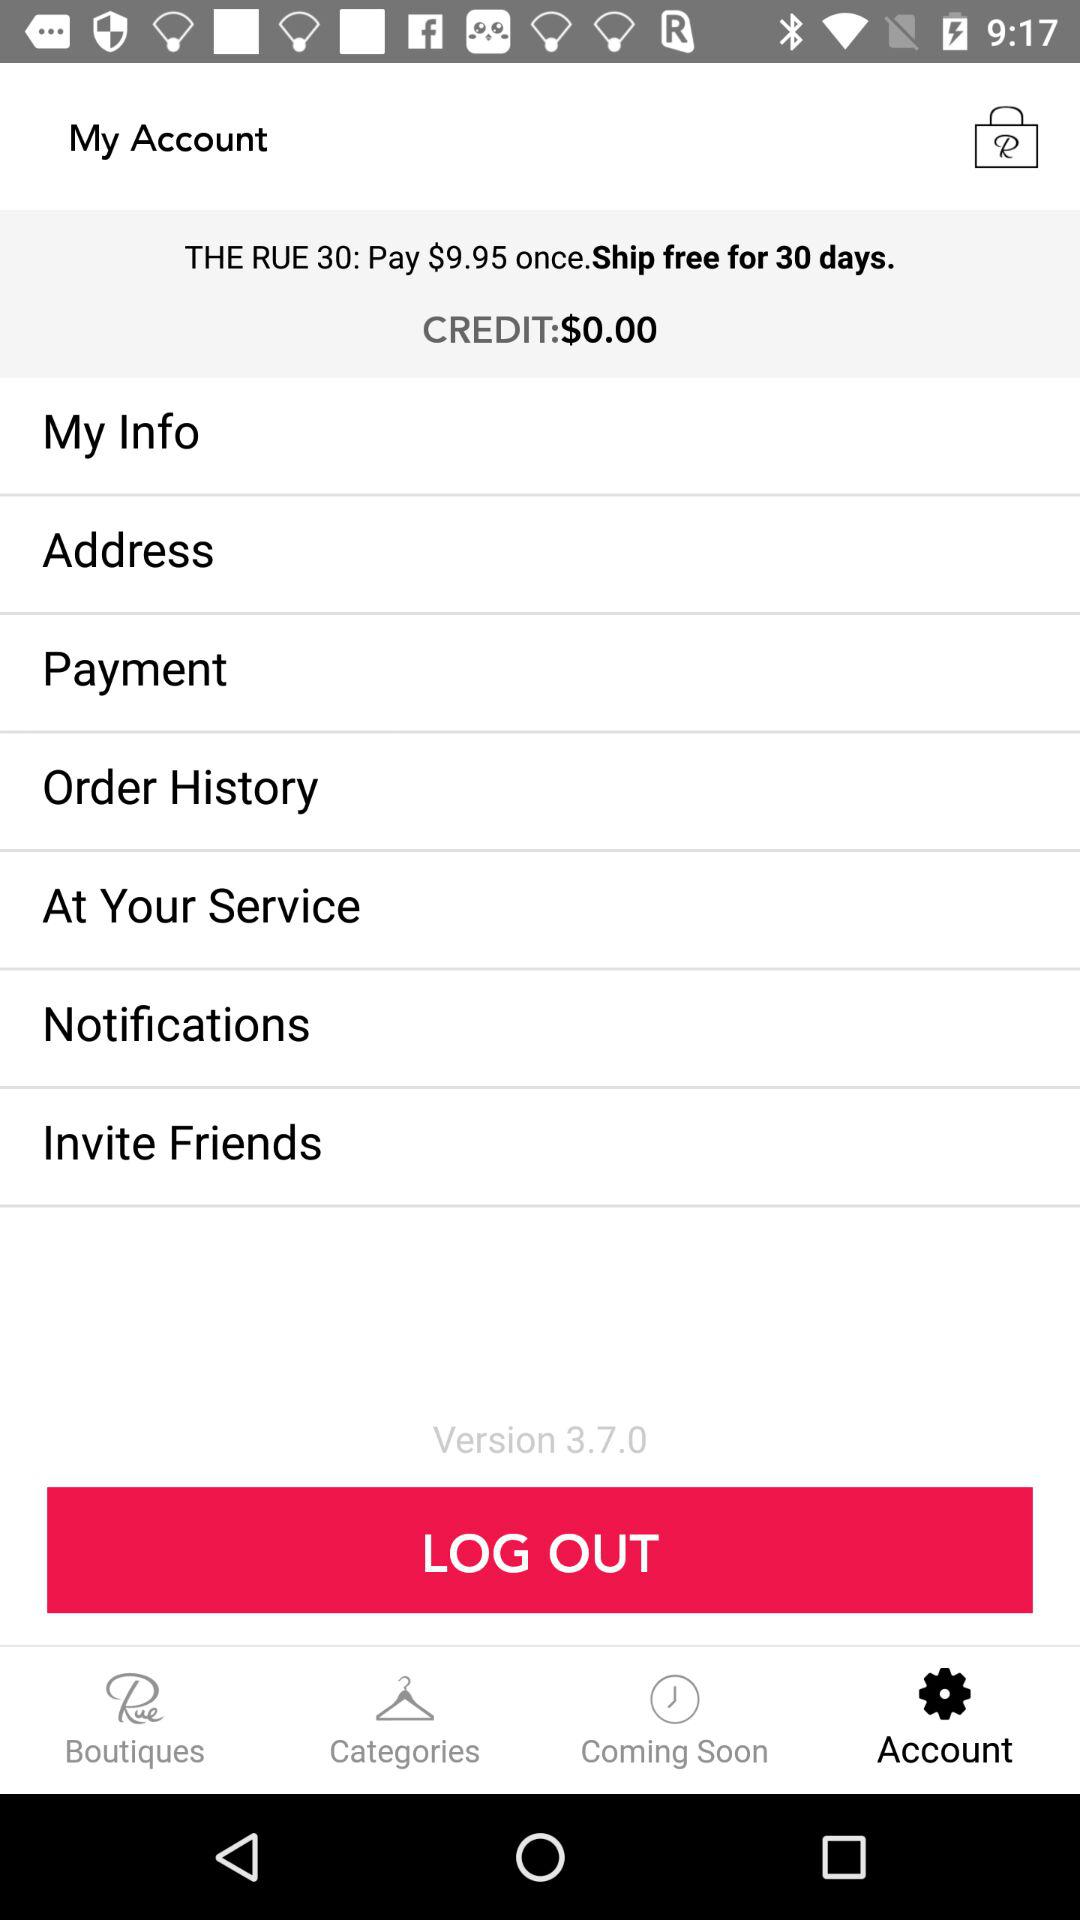What is the credit? The credit is $0.00. 